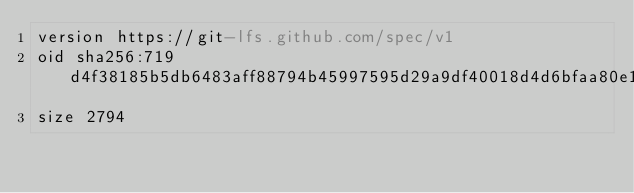Convert code to text. <code><loc_0><loc_0><loc_500><loc_500><_YAML_>version https://git-lfs.github.com/spec/v1
oid sha256:719d4f38185b5db6483aff88794b45997595d29a9df40018d4d6bfaa80e181f4
size 2794
</code> 